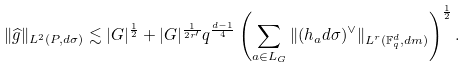Convert formula to latex. <formula><loc_0><loc_0><loc_500><loc_500>\| \widehat { g } \| _ { L ^ { 2 } ( P , d \sigma ) } \lesssim | G | ^ { \frac { 1 } { 2 } } + | G | ^ { \frac { 1 } { 2 r ^ { \prime } } } q ^ { \frac { d - 1 } { 4 } } \left ( \sum _ { a \in L _ { G } } \| ( h _ { a } d \sigma ) ^ { \vee } \| _ { L ^ { r } ( \mathbb { F } _ { q } ^ { d } , d m ) } \right ) ^ { \frac { 1 } { 2 } } .</formula> 